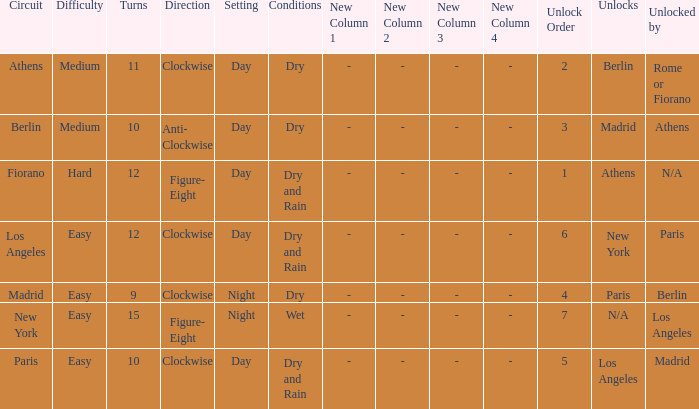What is the difficulty of the athens circuit? Medium. 